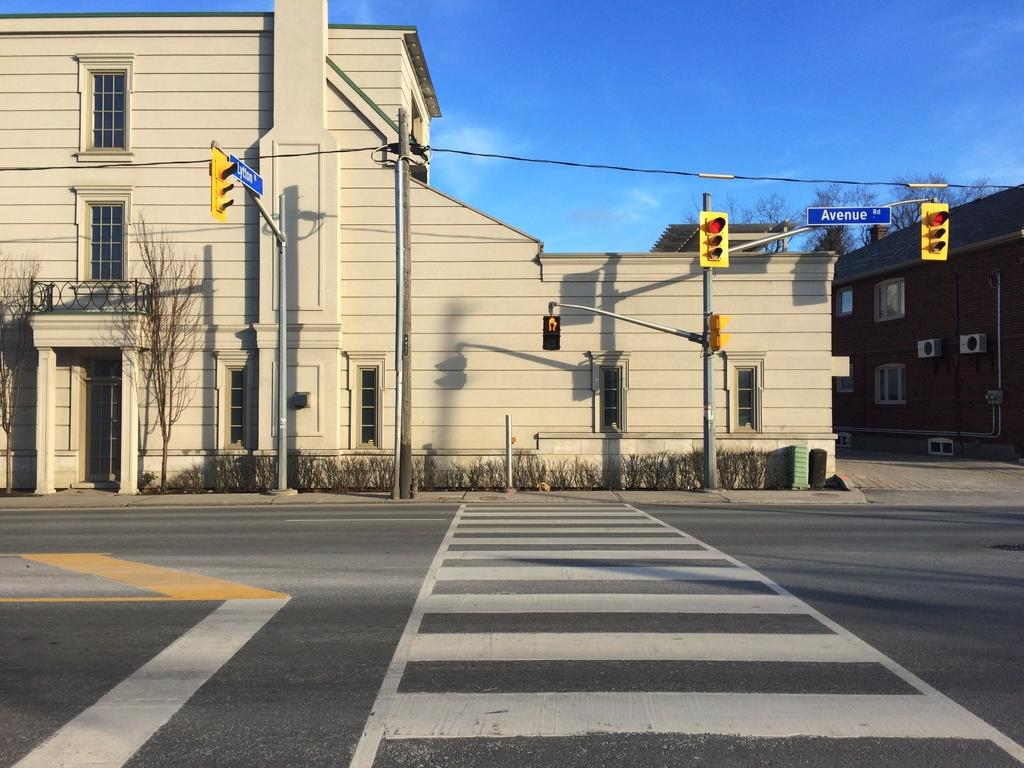<image>
Relay a brief, clear account of the picture shown. A road with white crosswalk painted lines and a large tan building and signal lights on the other side of it. 